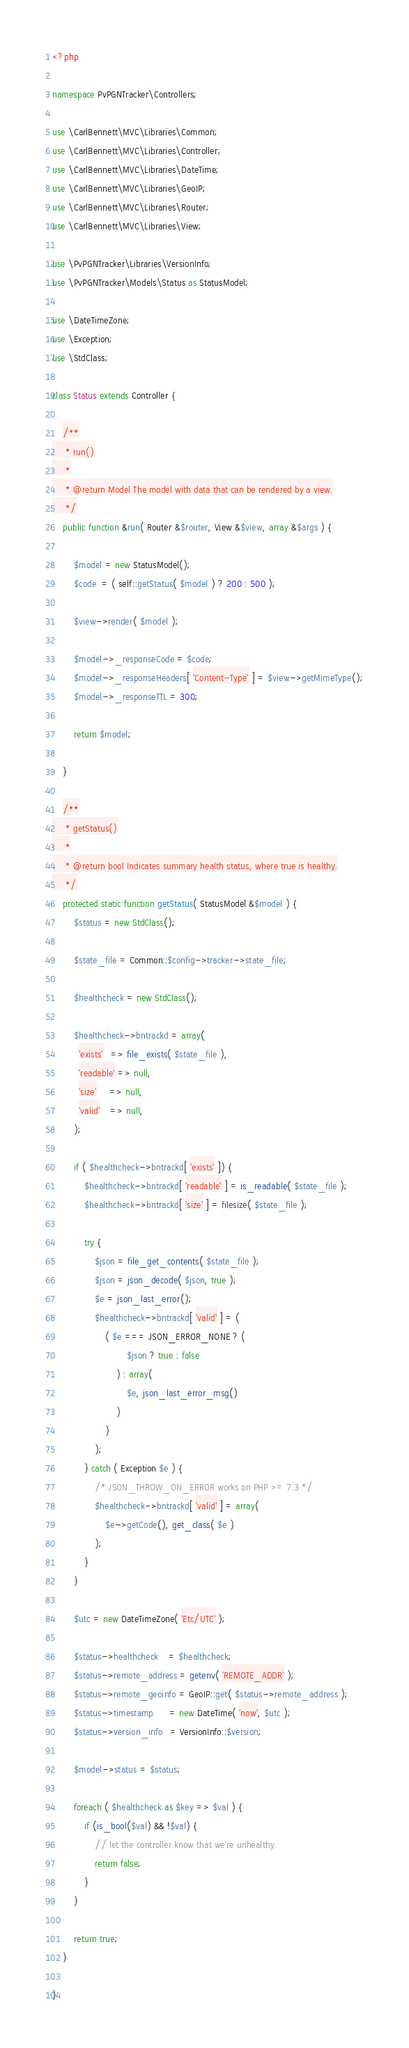Convert code to text. <code><loc_0><loc_0><loc_500><loc_500><_PHP_><?php

namespace PvPGNTracker\Controllers;

use \CarlBennett\MVC\Libraries\Common;
use \CarlBennett\MVC\Libraries\Controller;
use \CarlBennett\MVC\Libraries\DateTime;
use \CarlBennett\MVC\Libraries\GeoIP;
use \CarlBennett\MVC\Libraries\Router;
use \CarlBennett\MVC\Libraries\View;

use \PvPGNTracker\Libraries\VersionInfo;
use \PvPGNTracker\Models\Status as StatusModel;

use \DateTimeZone;
use \Exception;
use \StdClass;

class Status extends Controller {

    /**
     * run()
     *
     * @return Model The model with data that can be rendered by a view.
     */
    public function &run( Router &$router, View &$view, array &$args ) {

        $model = new StatusModel();
        $code  = ( self::getStatus( $model ) ? 200 : 500 );

        $view->render( $model );

        $model->_responseCode = $code;
        $model->_responseHeaders[ 'Content-Type' ] = $view->getMimeType();
        $model->_responseTTL = 300;

        return $model;

    }

    /**
     * getStatus()
     *
     * @return bool Indicates summary health status, where true is healthy.
     */
    protected static function getStatus( StatusModel &$model ) {
        $status = new StdClass();

        $state_file = Common::$config->tracker->state_file;

        $healthcheck = new StdClass();

        $healthcheck->bntrackd = array(
          'exists'   => file_exists( $state_file ),
          'readable' => null,
          'size'     => null,
          'valid'    => null,
        );

        if ( $healthcheck->bntrackd[ 'exists' ]) {
            $healthcheck->bntrackd[ 'readable' ] = is_readable( $state_file );
            $healthcheck->bntrackd[ 'size' ] = filesize( $state_file );

            try {
                $json = file_get_contents( $state_file );
                $json = json_decode( $json, true );
                $e = json_last_error();
                $healthcheck->bntrackd[ 'valid' ] = (
                    ( $e === JSON_ERROR_NONE ? (
                            $json ? true : false
                        ) : array(
                            $e, json_last_error_msg()
                        )
                    )
                );
            } catch ( Exception $e ) {
                /* JSON_THROW_ON_ERROR works on PHP >= 7.3 */
                $healthcheck->bntrackd[ 'valid' ] = array(
                    $e->getCode(), get_class( $e )
                );
            }
        }

        $utc = new DateTimeZone( 'Etc/UTC' );

        $status->healthcheck    = $healthcheck;
        $status->remote_address = getenv( 'REMOTE_ADDR' );
        $status->remote_geoinfo = GeoIP::get( $status->remote_address );
        $status->timestamp      = new DateTime( 'now', $utc );
        $status->version_info   = VersionInfo::$version;

        $model->status = $status;

        foreach ( $healthcheck as $key => $val ) {
            if (is_bool($val) && !$val) {
                // let the controller know that we're unhealthy.
                return false;
            }
        }

        return true;
    }

}
</code> 